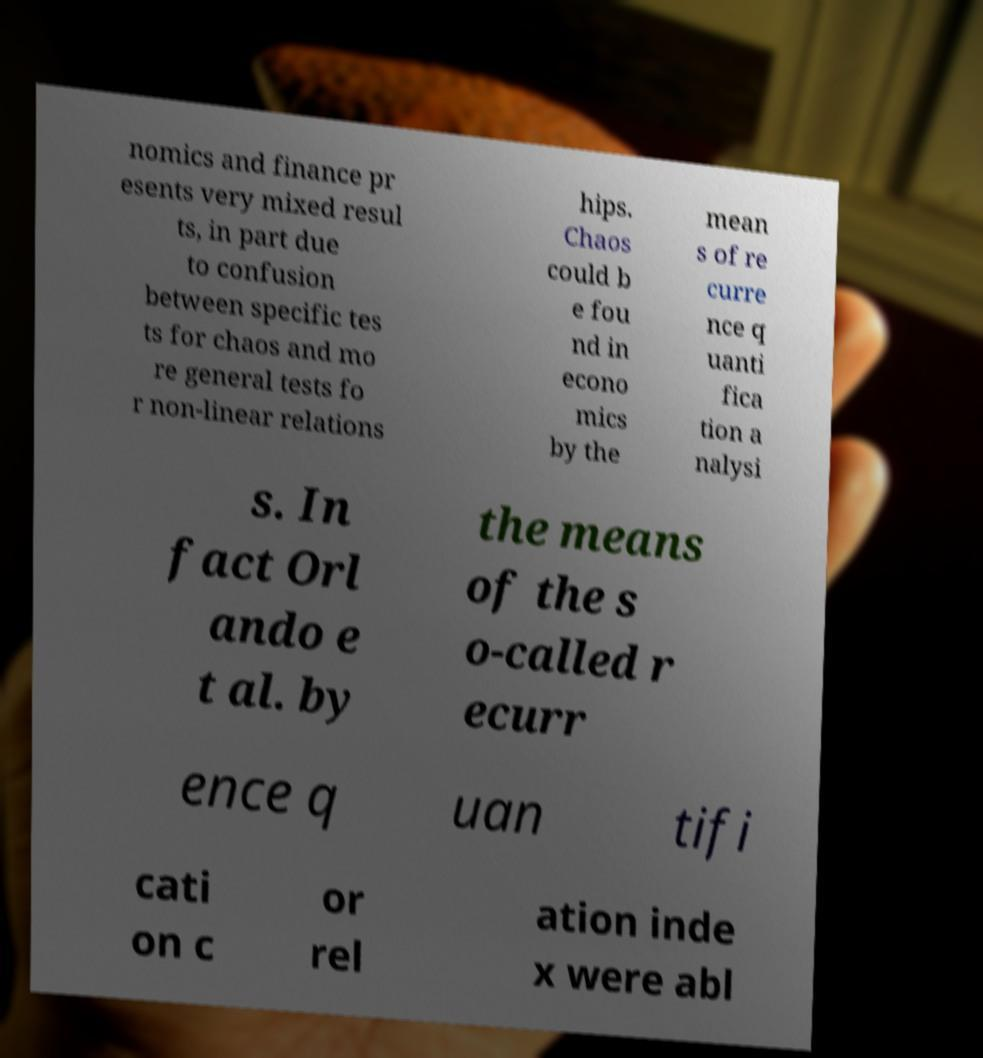Can you accurately transcribe the text from the provided image for me? nomics and finance pr esents very mixed resul ts, in part due to confusion between specific tes ts for chaos and mo re general tests fo r non-linear relations hips. Chaos could b e fou nd in econo mics by the mean s of re curre nce q uanti fica tion a nalysi s. In fact Orl ando e t al. by the means of the s o-called r ecurr ence q uan tifi cati on c or rel ation inde x were abl 